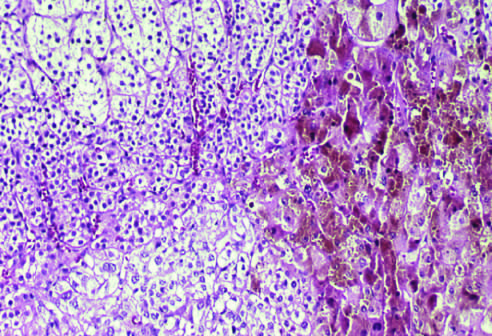what are composed of cells containing lipofuscin pigment, seen in the right part of the field on histologic examination?
Answer the question using a single word or phrase. The nodules 